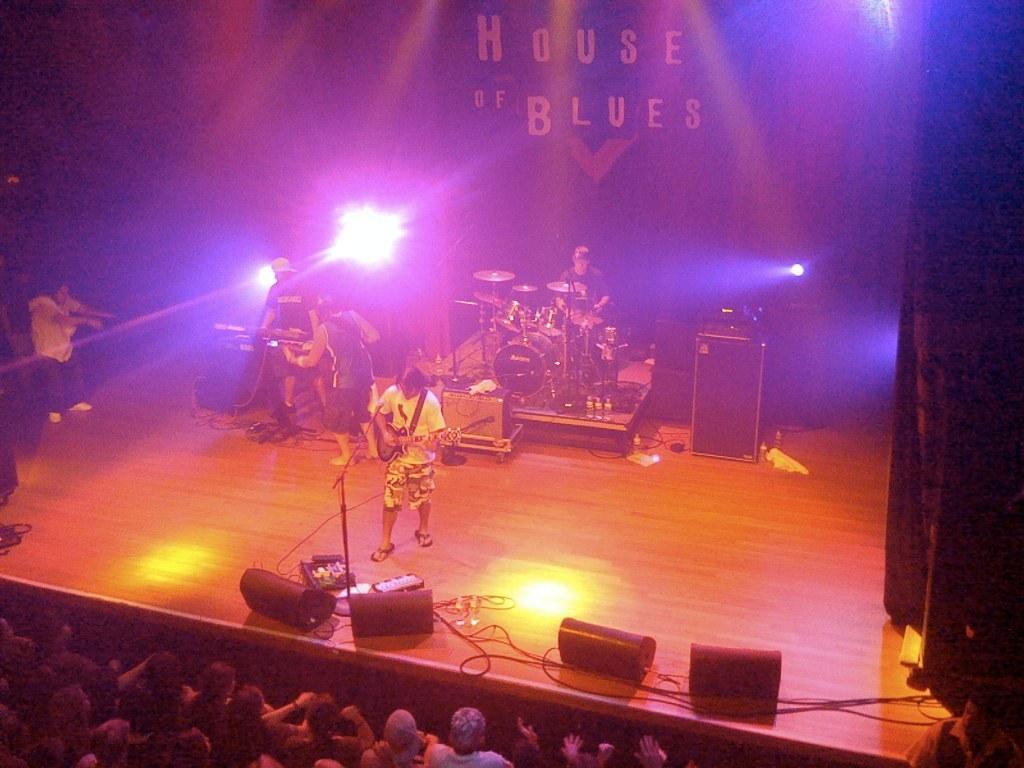Could you give a brief overview of what you see in this image? In the foreground of this image, on the bottom, there are persons. In the middle, there are persons standing and playing musical instruments. We can also see few lights, curtain, speaker boxes and lights in the background. 